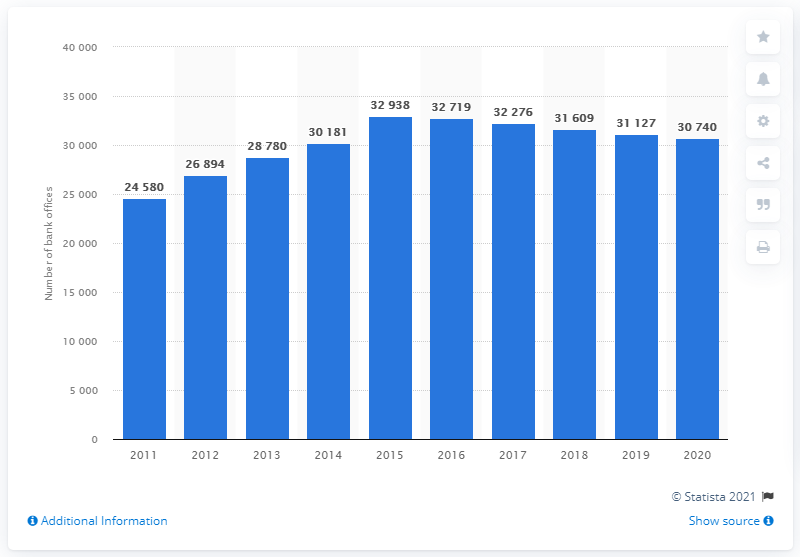Draw attention to some important aspects in this diagram. In 2020, there were 30,740 bank offices in Indonesia. 